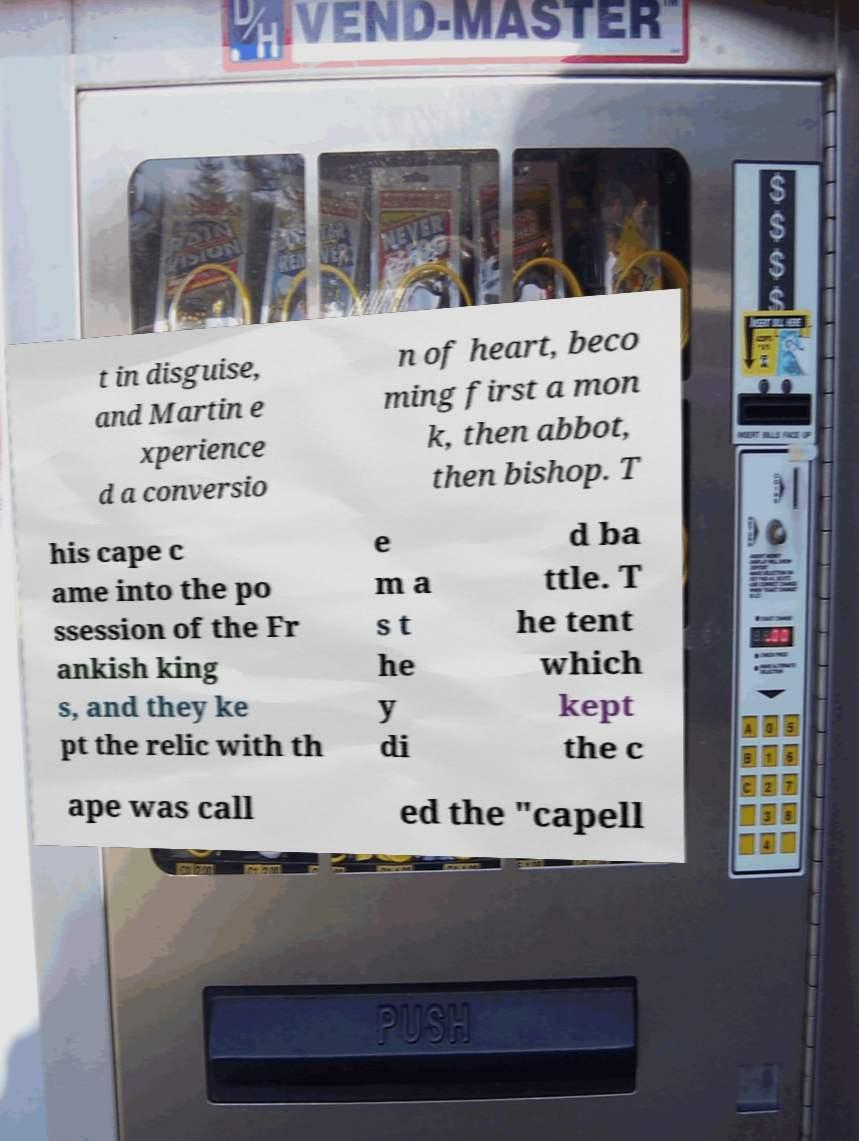I need the written content from this picture converted into text. Can you do that? t in disguise, and Martin e xperience d a conversio n of heart, beco ming first a mon k, then abbot, then bishop. T his cape c ame into the po ssession of the Fr ankish king s, and they ke pt the relic with th e m a s t he y di d ba ttle. T he tent which kept the c ape was call ed the "capell 